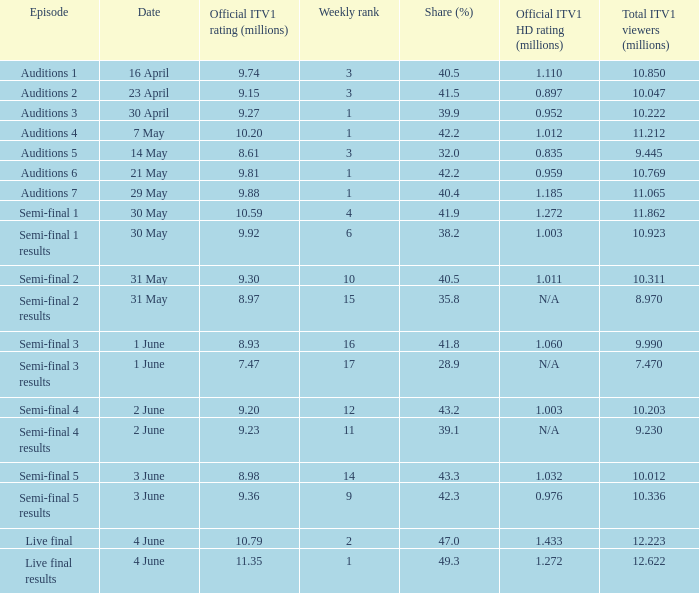What was the official ITV1 HD rating in millions for the episode that had an official ITV1 rating of 8.98 million? 1.032. 